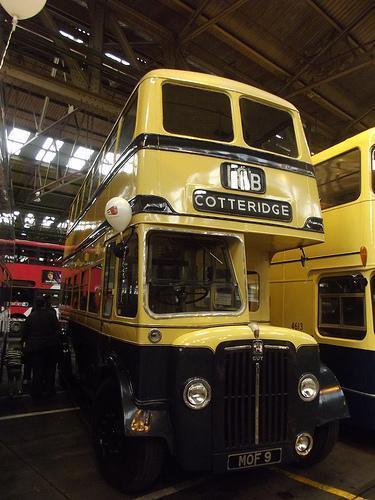How many green buses are in this image?
Give a very brief answer. 0. 